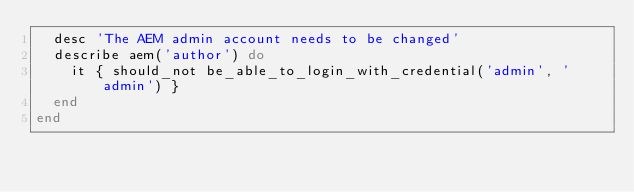Convert code to text. <code><loc_0><loc_0><loc_500><loc_500><_Ruby_>  desc 'The AEM admin account needs to be changed'
  describe aem('author') do
    it { should_not be_able_to_login_with_credential('admin', 'admin') }
  end
end
</code> 